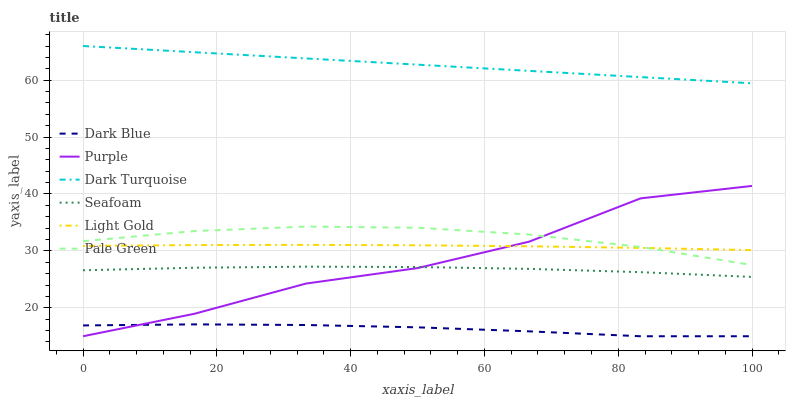Does Seafoam have the minimum area under the curve?
Answer yes or no. No. Does Seafoam have the maximum area under the curve?
Answer yes or no. No. Is Seafoam the smoothest?
Answer yes or no. No. Is Seafoam the roughest?
Answer yes or no. No. Does Seafoam have the lowest value?
Answer yes or no. No. Does Seafoam have the highest value?
Answer yes or no. No. Is Dark Blue less than Dark Turquoise?
Answer yes or no. Yes. Is Pale Green greater than Seafoam?
Answer yes or no. Yes. Does Dark Blue intersect Dark Turquoise?
Answer yes or no. No. 